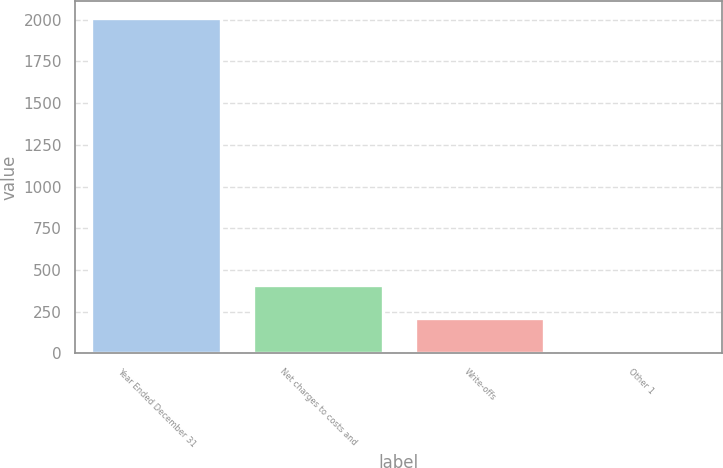Convert chart to OTSL. <chart><loc_0><loc_0><loc_500><loc_500><bar_chart><fcel>Year Ended December 31<fcel>Net charges to costs and<fcel>Write-offs<fcel>Other 1<nl><fcel>2010<fcel>410<fcel>210<fcel>10<nl></chart> 